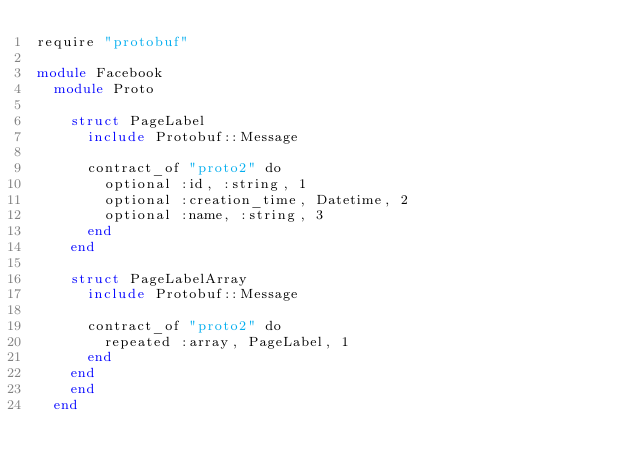<code> <loc_0><loc_0><loc_500><loc_500><_Crystal_>require "protobuf"

module Facebook
  module Proto
    
    struct PageLabel
      include Protobuf::Message
      
      contract_of "proto2" do
        optional :id, :string, 1
        optional :creation_time, Datetime, 2
        optional :name, :string, 3
      end
    end
    
    struct PageLabelArray
      include Protobuf::Message
      
      contract_of "proto2" do
        repeated :array, PageLabel, 1
      end
    end
    end
  end
</code> 